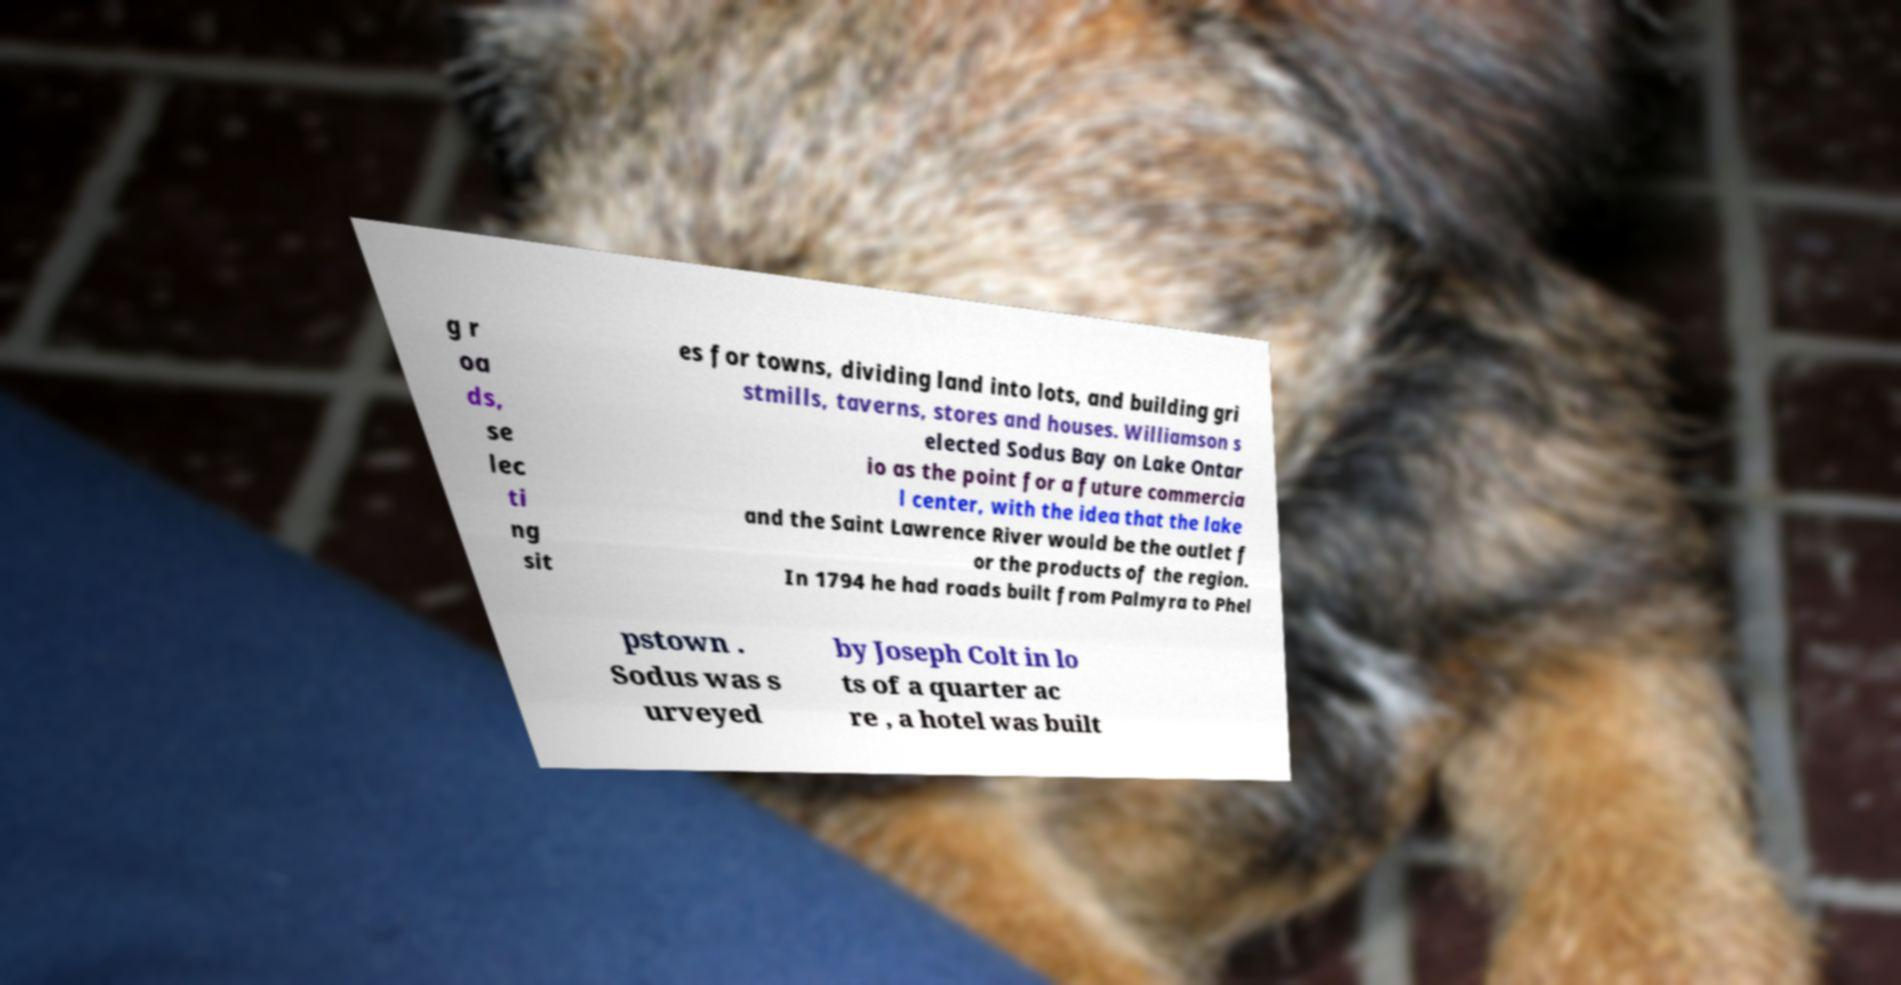Please identify and transcribe the text found in this image. g r oa ds, se lec ti ng sit es for towns, dividing land into lots, and building gri stmills, taverns, stores and houses. Williamson s elected Sodus Bay on Lake Ontar io as the point for a future commercia l center, with the idea that the lake and the Saint Lawrence River would be the outlet f or the products of the region. In 1794 he had roads built from Palmyra to Phel pstown . Sodus was s urveyed by Joseph Colt in lo ts of a quarter ac re , a hotel was built 